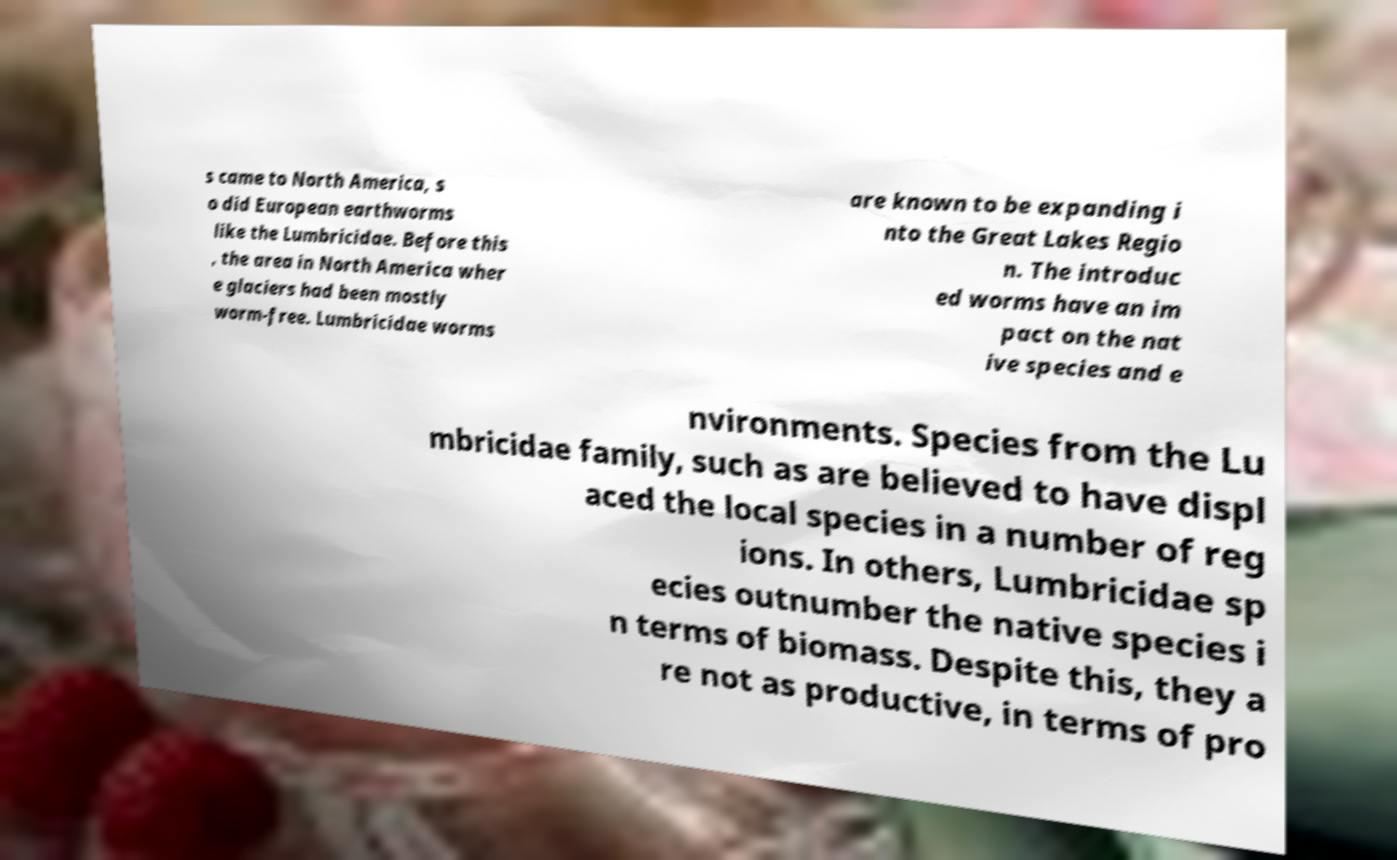Can you read and provide the text displayed in the image?This photo seems to have some interesting text. Can you extract and type it out for me? s came to North America, s o did European earthworms like the Lumbricidae. Before this , the area in North America wher e glaciers had been mostly worm-free. Lumbricidae worms are known to be expanding i nto the Great Lakes Regio n. The introduc ed worms have an im pact on the nat ive species and e nvironments. Species from the Lu mbricidae family, such as are believed to have displ aced the local species in a number of reg ions. In others, Lumbricidae sp ecies outnumber the native species i n terms of biomass. Despite this, they a re not as productive, in terms of pro 